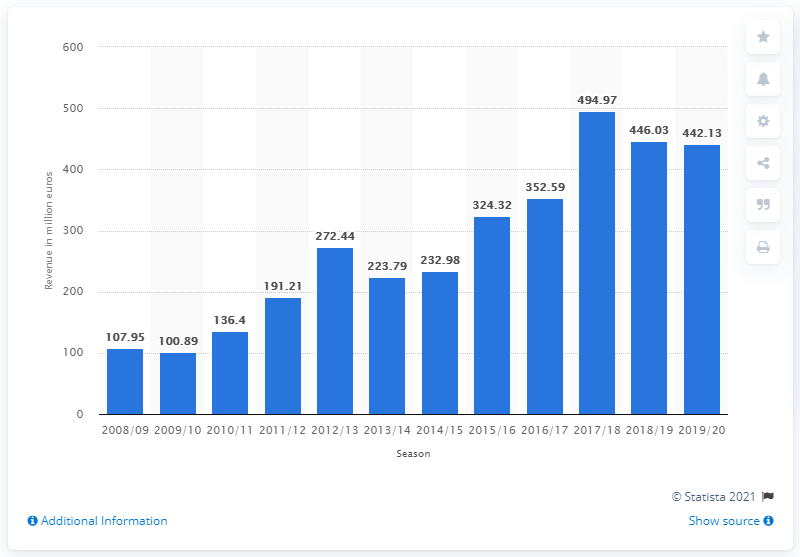Point out several critical features in this image. In the 2019/20 season, Borussia Dortmund generated a revenue of 442.13 million euros. In the 2008/09 season, Borussia Dortmund was competing. In the 2019/2020 season, the revenue for Borussia Dortmund reached a staggering 442.13 million euros. 